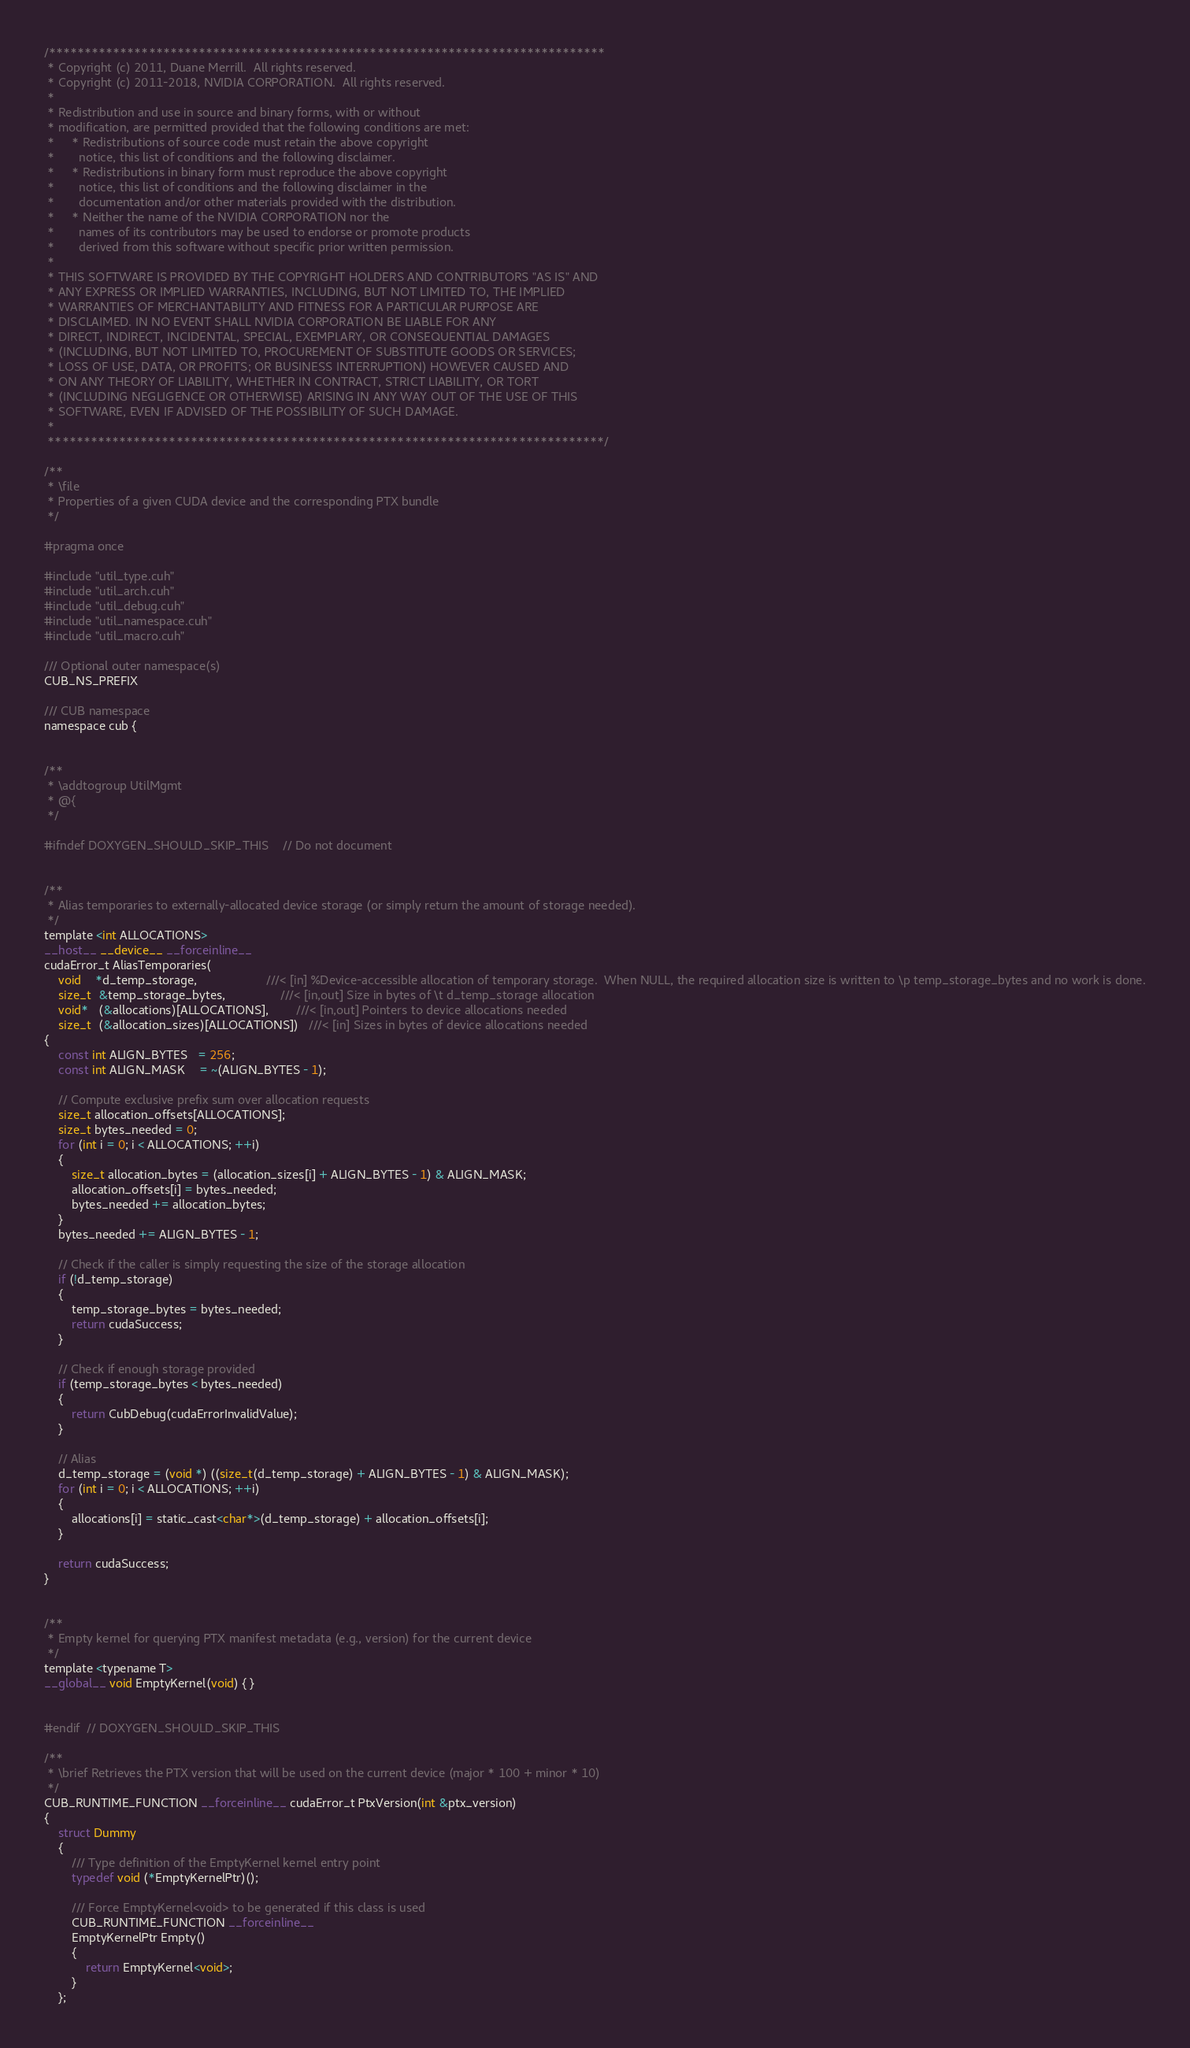Convert code to text. <code><loc_0><loc_0><loc_500><loc_500><_Cuda_>/******************************************************************************
 * Copyright (c) 2011, Duane Merrill.  All rights reserved.
 * Copyright (c) 2011-2018, NVIDIA CORPORATION.  All rights reserved.
 * 
 * Redistribution and use in source and binary forms, with or without
 * modification, are permitted provided that the following conditions are met:
 *     * Redistributions of source code must retain the above copyright
 *       notice, this list of conditions and the following disclaimer.
 *     * Redistributions in binary form must reproduce the above copyright
 *       notice, this list of conditions and the following disclaimer in the
 *       documentation and/or other materials provided with the distribution.
 *     * Neither the name of the NVIDIA CORPORATION nor the
 *       names of its contributors may be used to endorse or promote products
 *       derived from this software without specific prior written permission.
 * 
 * THIS SOFTWARE IS PROVIDED BY THE COPYRIGHT HOLDERS AND CONTRIBUTORS "AS IS" AND
 * ANY EXPRESS OR IMPLIED WARRANTIES, INCLUDING, BUT NOT LIMITED TO, THE IMPLIED
 * WARRANTIES OF MERCHANTABILITY AND FITNESS FOR A PARTICULAR PURPOSE ARE
 * DISCLAIMED. IN NO EVENT SHALL NVIDIA CORPORATION BE LIABLE FOR ANY
 * DIRECT, INDIRECT, INCIDENTAL, SPECIAL, EXEMPLARY, OR CONSEQUENTIAL DAMAGES
 * (INCLUDING, BUT NOT LIMITED TO, PROCUREMENT OF SUBSTITUTE GOODS OR SERVICES;
 * LOSS OF USE, DATA, OR PROFITS; OR BUSINESS INTERRUPTION) HOWEVER CAUSED AND
 * ON ANY THEORY OF LIABILITY, WHETHER IN CONTRACT, STRICT LIABILITY, OR TORT
 * (INCLUDING NEGLIGENCE OR OTHERWISE) ARISING IN ANY WAY OUT OF THE USE OF THIS
 * SOFTWARE, EVEN IF ADVISED OF THE POSSIBILITY OF SUCH DAMAGE.
 *
 ******************************************************************************/

/**
 * \file
 * Properties of a given CUDA device and the corresponding PTX bundle
 */

#pragma once

#include "util_type.cuh"
#include "util_arch.cuh"
#include "util_debug.cuh"
#include "util_namespace.cuh"
#include "util_macro.cuh"

/// Optional outer namespace(s)
CUB_NS_PREFIX

/// CUB namespace
namespace cub {


/**
 * \addtogroup UtilMgmt
 * @{
 */

#ifndef DOXYGEN_SHOULD_SKIP_THIS    // Do not document


/**
 * Alias temporaries to externally-allocated device storage (or simply return the amount of storage needed).
 */
template <int ALLOCATIONS>
__host__ __device__ __forceinline__
cudaError_t AliasTemporaries(
    void    *d_temp_storage,                    ///< [in] %Device-accessible allocation of temporary storage.  When NULL, the required allocation size is written to \p temp_storage_bytes and no work is done.
    size_t  &temp_storage_bytes,                ///< [in,out] Size in bytes of \t d_temp_storage allocation
    void*   (&allocations)[ALLOCATIONS],        ///< [in,out] Pointers to device allocations needed
    size_t  (&allocation_sizes)[ALLOCATIONS])   ///< [in] Sizes in bytes of device allocations needed
{
    const int ALIGN_BYTES   = 256;
    const int ALIGN_MASK    = ~(ALIGN_BYTES - 1);

    // Compute exclusive prefix sum over allocation requests
    size_t allocation_offsets[ALLOCATIONS];
    size_t bytes_needed = 0;
    for (int i = 0; i < ALLOCATIONS; ++i)
    {
        size_t allocation_bytes = (allocation_sizes[i] + ALIGN_BYTES - 1) & ALIGN_MASK;
        allocation_offsets[i] = bytes_needed;
        bytes_needed += allocation_bytes;
    }
    bytes_needed += ALIGN_BYTES - 1;

    // Check if the caller is simply requesting the size of the storage allocation
    if (!d_temp_storage)
    {
        temp_storage_bytes = bytes_needed;
        return cudaSuccess;
    }

    // Check if enough storage provided
    if (temp_storage_bytes < bytes_needed)
    {
        return CubDebug(cudaErrorInvalidValue);
    }

    // Alias
    d_temp_storage = (void *) ((size_t(d_temp_storage) + ALIGN_BYTES - 1) & ALIGN_MASK);
    for (int i = 0; i < ALLOCATIONS; ++i)
    {
        allocations[i] = static_cast<char*>(d_temp_storage) + allocation_offsets[i];
    }

    return cudaSuccess;
}


/**
 * Empty kernel for querying PTX manifest metadata (e.g., version) for the current device
 */
template <typename T>
__global__ void EmptyKernel(void) { }


#endif  // DOXYGEN_SHOULD_SKIP_THIS

/**
 * \brief Retrieves the PTX version that will be used on the current device (major * 100 + minor * 10)
 */
CUB_RUNTIME_FUNCTION __forceinline__ cudaError_t PtxVersion(int &ptx_version)
{
    struct Dummy
    {
        /// Type definition of the EmptyKernel kernel entry point
        typedef void (*EmptyKernelPtr)();

        /// Force EmptyKernel<void> to be generated if this class is used
        CUB_RUNTIME_FUNCTION __forceinline__
        EmptyKernelPtr Empty()
        {
            return EmptyKernel<void>;
        }
    };

</code> 